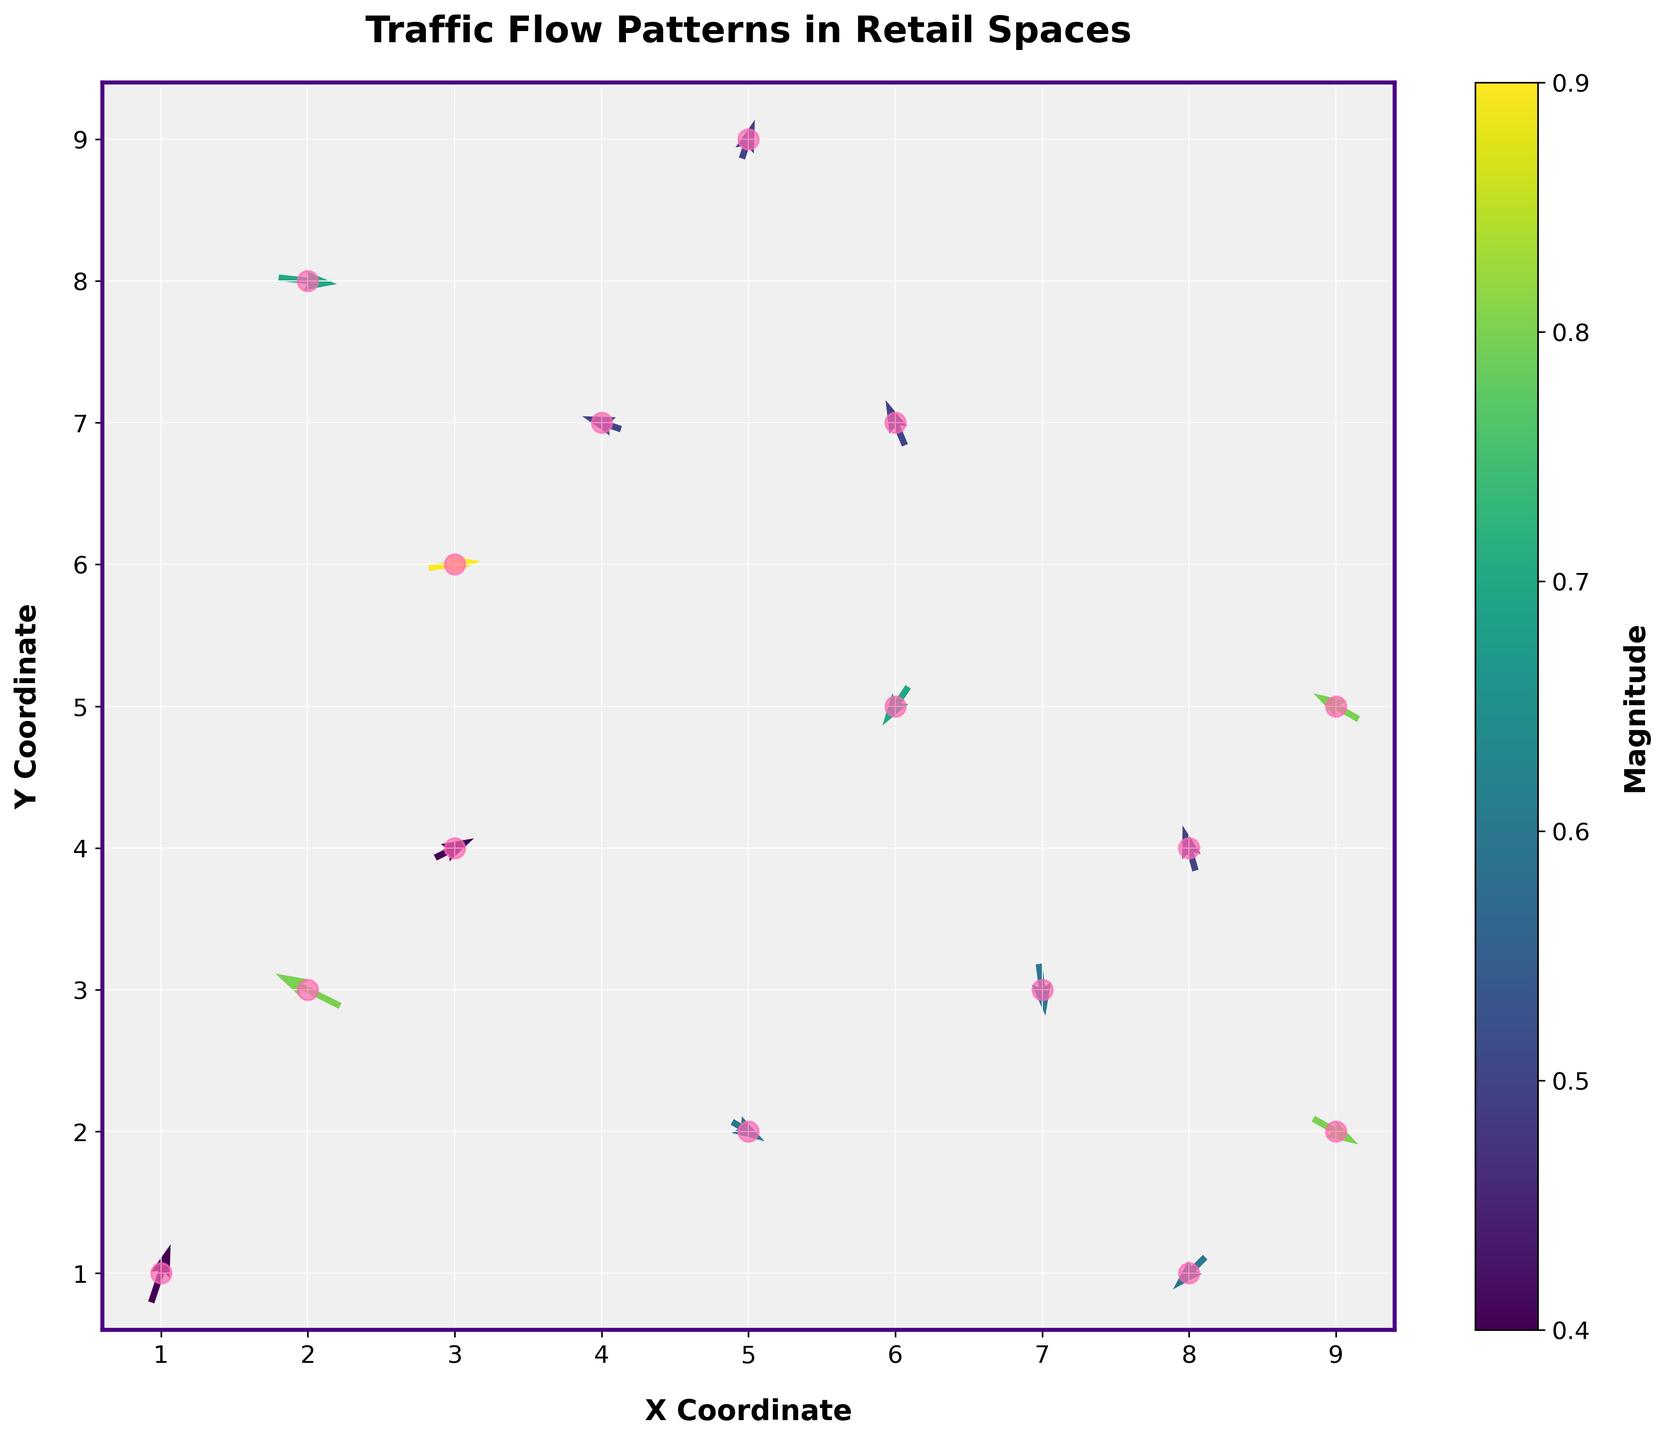What is the title of the plot? The title is displayed at the top of the plot, clearly indicating the subject of the visualization.
Answer: Traffic Flow Patterns in Retail Spaces How many data points are there in the plot? Each arrow represents a movement vector and can be counted visually.
Answer: 15 What is the background color of the plot? The background color can be seen directly behind the plot elements.
Answer: Light grey What is the color range used to indicate the magnitude? The colorbar beside the plot shows the range of colors used to represent different magnitudes.
Answer: Viridis color map Which data point has the highest magnitude? Look at the colors of the arrows and reference the colorbar to determine the highest magnitude value.
Answer: The data point at (3, 6) What is the overall direction of the flow at point (6, 7)? The direction can be determined by the orientation of the arrow at coordinates (6, 7).
Answer: Predominantly upwards and slightly to the right Which direction does the arrow at (5, 9) point? The direction of the arrow is visually apparent in the quiver plot and indicates movement.
Answer: Upwards Comparing the arrows at (7, 3) and (9, 2), which one indicates a stronger magnitude? Compare the colors of the arrows relative to the colorbar to see which arrow represents a stronger magnitude.
Answer: The arrow at (9, 2) What would the approximate average magnitude of all vectors be? To find the average magnitude, sum all magnitude values and divide by the number of data points: (0.8 + 0.6 + 0.5 + 0.9 + 0.7 + 0.4 + 0.5 + 0.6 + 0.8 + 0.7 + 0.5 + 0.6 + 0.4 + 0.5 + 0.8) / 15 ≈ 0.6.
Answer: Around 0.6 Between which x and y coordinates are the largest concentration of arrows located? Visually inspect the plot to find where the arrows are densest.
Answer: Between coordinates (3, 4)-(6, 7) 